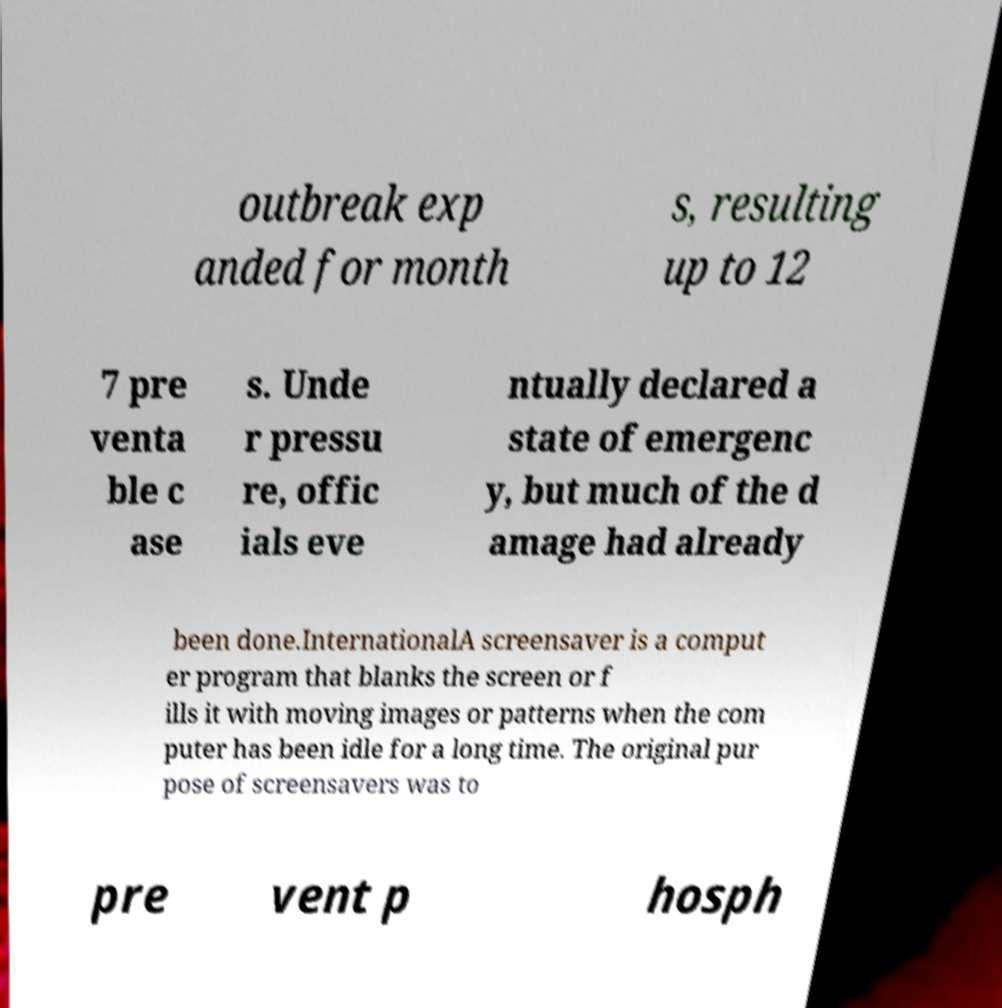Can you accurately transcribe the text from the provided image for me? outbreak exp anded for month s, resulting up to 12 7 pre venta ble c ase s. Unde r pressu re, offic ials eve ntually declared a state of emergenc y, but much of the d amage had already been done.InternationalA screensaver is a comput er program that blanks the screen or f ills it with moving images or patterns when the com puter has been idle for a long time. The original pur pose of screensavers was to pre vent p hosph 